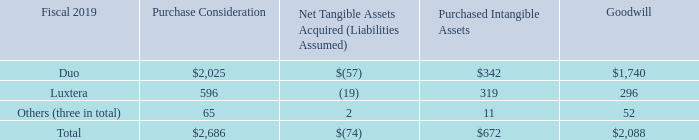4. Acquisitions and Divestitures
(a) Acquisition Summary
We completed five acquisitions during fiscal 2019. A summary of the allocation of the total purchase consideration is presented as follows (in millions):
On September 28, 2018, we completed our acquisition of privately held Duo Security, Inc. (“Duo”), a leading provider of unified access security and multi-factor authentication delivered through the cloud. Revenue from the Duo acquisition has been included in our Security product category.
On February 6, 2019, we completed our acquisition of Luxtera, Inc. (“Luxtera”), a privately held semiconductor company. Revenue from the Luxtera acquisition has been included in our Infrastructure Platforms product category.
The total purchase consideration related to our acquisitions completed during fiscal 2019 consisted of cash consideration and vested share-based awards assumed. The total cash and cash equivalents acquired from these acquisitions was approximately $100 million.
What did the total purchase consideration related to our acquisitions completed during fiscal 2019 consist of? Cash consideration and vested share-based awards assumed. What company did the company acquire in fiscal 2019? Luxtera, inc. (“luxtera”), a privately held semiconductor company. What the purchase consideration from Luxtera?
Answer scale should be: million. 596. What was the difference in Goodwill between Duo and Luxtera?
Answer scale should be: million. 1,740-296
Answer: 1444. What was the difference in Purchased intangible assets between Luxtera and Others?
Answer scale should be: million. 319-11
Answer: 308. What is the acquisition with the highest Purchase Consideration? Under the column for Purchase Considerations, excluding the Total row,find the largest number and the corresponding acquisition in COL2 
Answer: duo. 